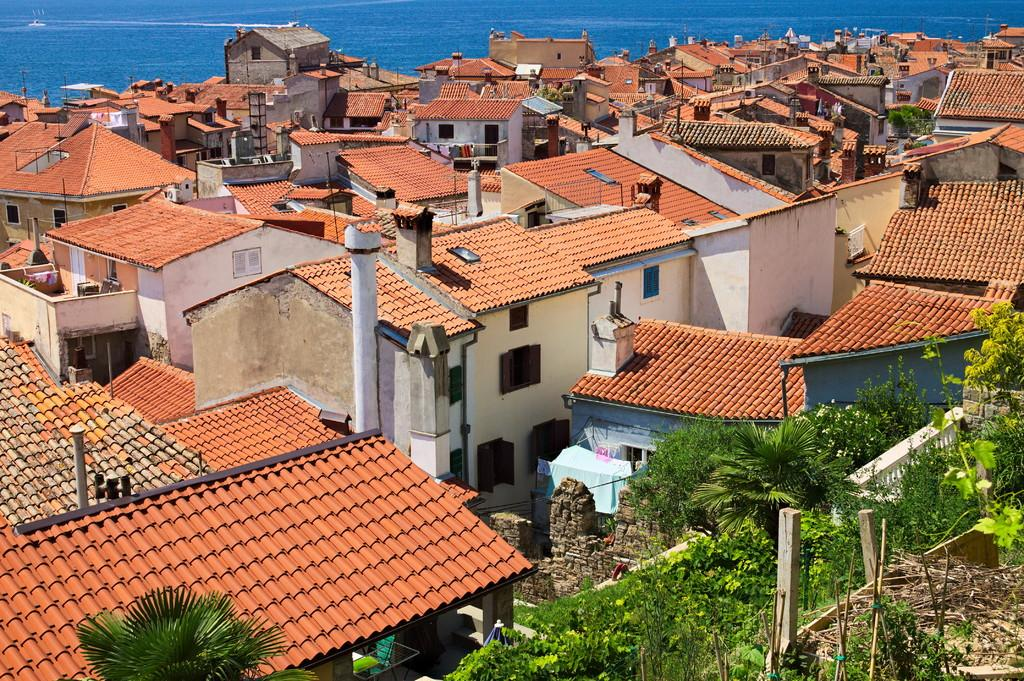What type of structures can be seen in the image? There are roofs of buildings in the image. What other elements can be found at the bottom of the image? There are trees at the bottom of the image. What can be seen in the distance in the image? There is water visible in the background of the image. What object is present in the image that is related to plumbing or drainage? There is a pipe in the image. How many pizzas are being delivered to the moon in the image? There are no pizzas or references to the moon in the image. Can you describe the people jumping in the image? There are no people or jumping actions depicted in the image. 